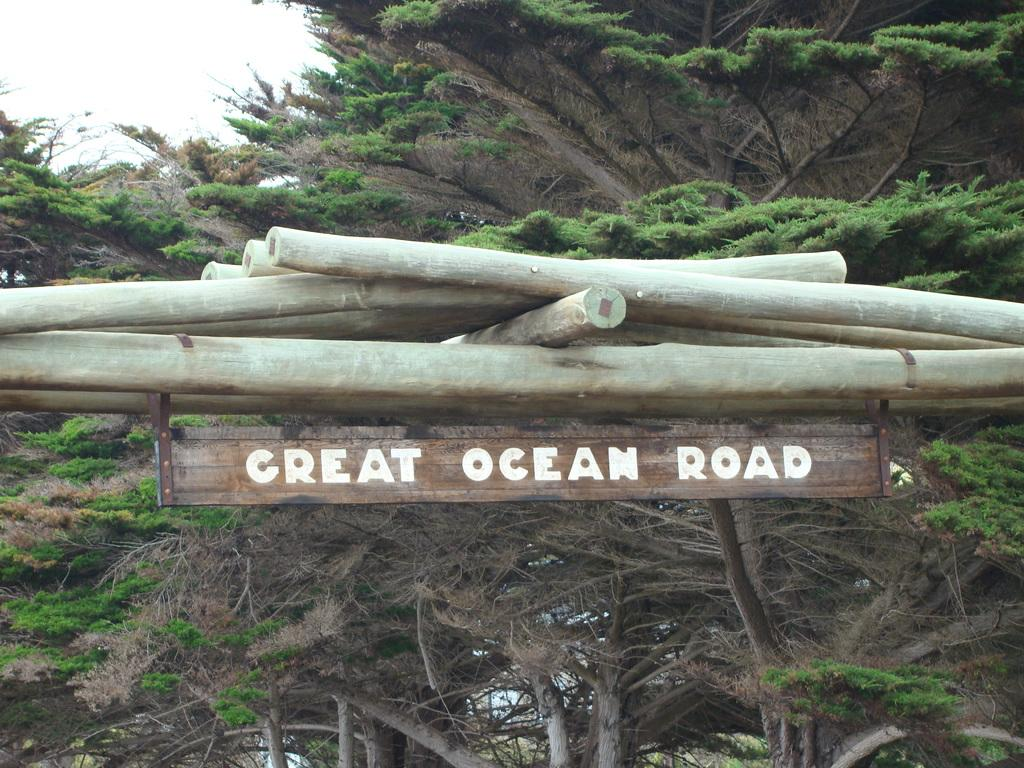What object is present in the image that has a wooden stick? There is a board in the image that is on a wooden stick. What can be found on the board? There is text on the board. What type of natural environment is visible in the background of the image? Trees are visible in the background of the image. What is visible at the top of the image? The sky is visible at the top of the image. What type of book is being used to treat the disease in the image? There is no book or disease present in the image; it features a board with text on a wooden stick, trees in the background, and a visible sky. 